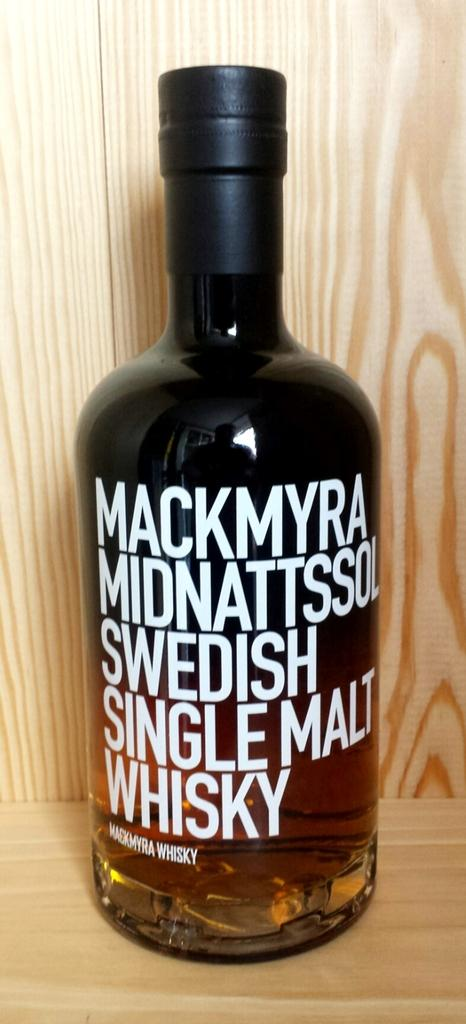<image>
Provide a brief description of the given image. A large, brown bottle of Swedish Single Malt Whiskey. 